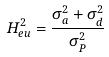Convert formula to latex. <formula><loc_0><loc_0><loc_500><loc_500>H _ { e u } ^ { 2 } = \frac { \sigma _ { a } ^ { 2 } + \sigma _ { d } ^ { 2 } } { \sigma _ { P } ^ { 2 } }</formula> 